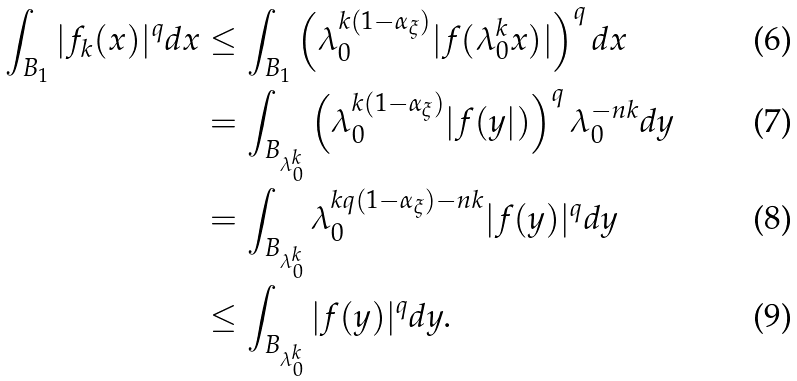<formula> <loc_0><loc_0><loc_500><loc_500>\int _ { B _ { 1 } } | f _ { k } ( x ) | ^ { q } d x & \leq \int _ { B _ { 1 } } \left ( \lambda ^ { k ( 1 - \alpha _ { \xi } ) } _ { 0 } | f ( \lambda ^ { k } _ { 0 } x ) | \right ) ^ { q } d x \\ & = \int _ { B _ { \lambda ^ { k } _ { 0 } } } \left ( \lambda ^ { k ( 1 - \alpha _ { \xi } ) } _ { 0 } | f ( y | ) \right ) ^ { q } \lambda ^ { - n k } _ { 0 } d y \\ & = \int _ { B _ { \lambda ^ { k } _ { 0 } } } \lambda ^ { k q ( 1 - \alpha _ { \xi } ) - n k } _ { 0 } | f ( y ) | ^ { q } d y \\ & \leq \int _ { B _ { \lambda ^ { k } _ { 0 } } } | f ( y ) | ^ { q } d y .</formula> 